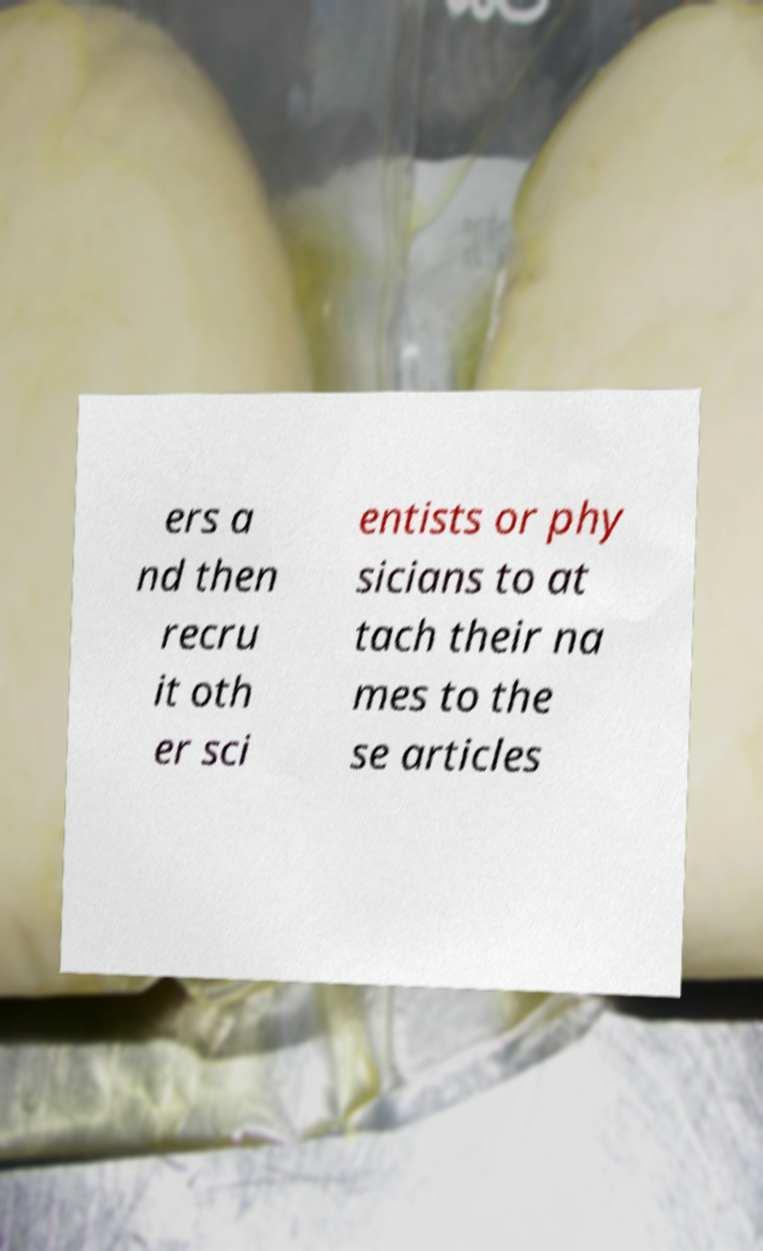For documentation purposes, I need the text within this image transcribed. Could you provide that? ers a nd then recru it oth er sci entists or phy sicians to at tach their na mes to the se articles 